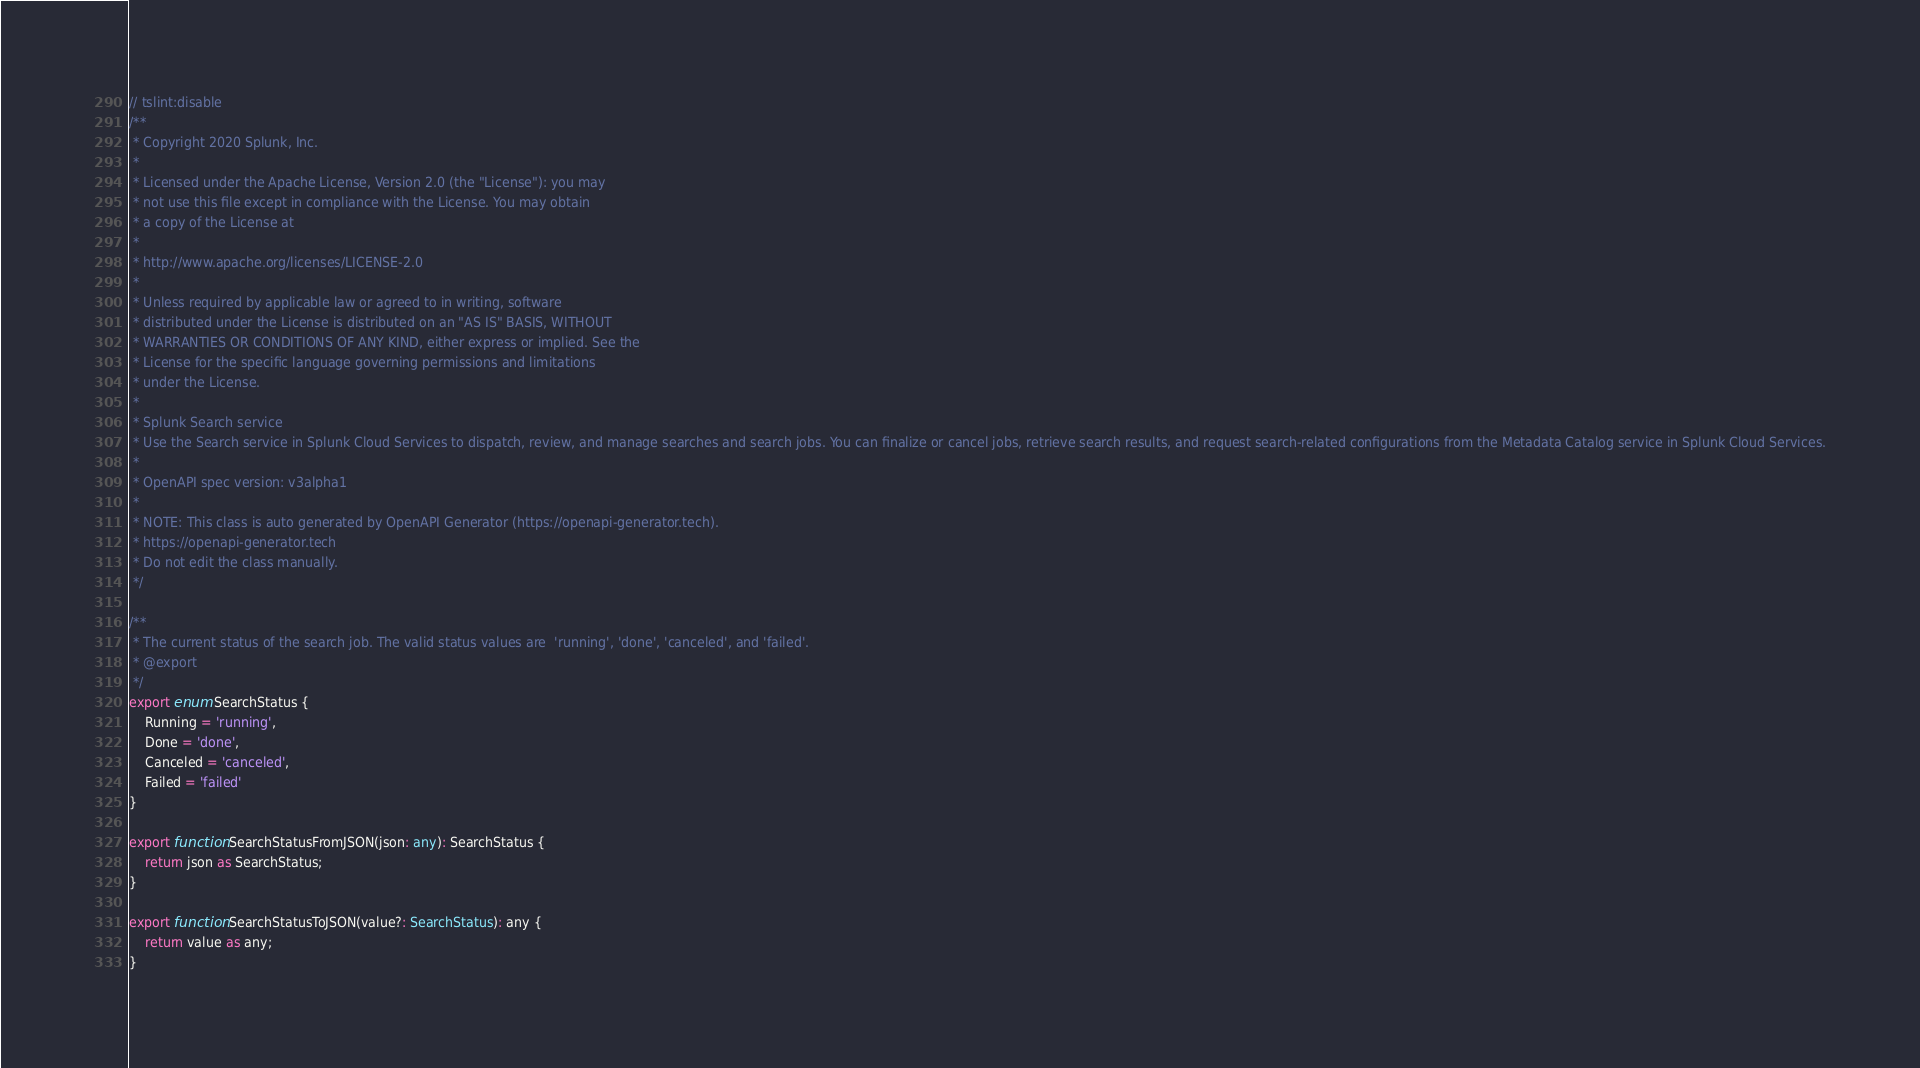Convert code to text. <code><loc_0><loc_0><loc_500><loc_500><_TypeScript_>// tslint:disable
/**
 * Copyright 2020 Splunk, Inc.
 *
 * Licensed under the Apache License, Version 2.0 (the "License"): you may
 * not use this file except in compliance with the License. You may obtain
 * a copy of the License at
 *
 * http://www.apache.org/licenses/LICENSE-2.0
 *
 * Unless required by applicable law or agreed to in writing, software
 * distributed under the License is distributed on an "AS IS" BASIS, WITHOUT
 * WARRANTIES OR CONDITIONS OF ANY KIND, either express or implied. See the
 * License for the specific language governing permissions and limitations
 * under the License.
 *
 * Splunk Search service
 * Use the Search service in Splunk Cloud Services to dispatch, review, and manage searches and search jobs. You can finalize or cancel jobs, retrieve search results, and request search-related configurations from the Metadata Catalog service in Splunk Cloud Services.
 *
 * OpenAPI spec version: v3alpha1 
 *
 * NOTE: This class is auto generated by OpenAPI Generator (https://openapi-generator.tech).
 * https://openapi-generator.tech
 * Do not edit the class manually.
 */

/**
 * The current status of the search job. The valid status values are  'running', 'done', 'canceled', and 'failed'. 
 * @export
 */
export enum SearchStatus {
    Running = 'running',
    Done = 'done',
    Canceled = 'canceled',
    Failed = 'failed'
}

export function SearchStatusFromJSON(json: any): SearchStatus {
    return json as SearchStatus;
}

export function SearchStatusToJSON(value?: SearchStatus): any {
    return value as any;
}

</code> 